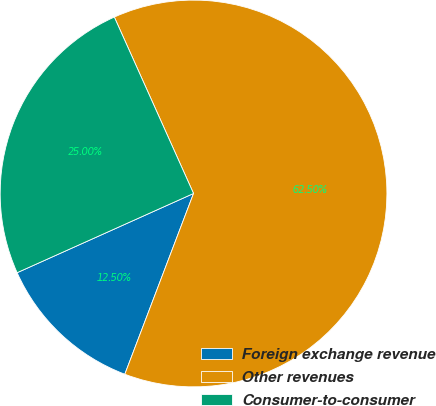Convert chart. <chart><loc_0><loc_0><loc_500><loc_500><pie_chart><fcel>Foreign exchange revenue<fcel>Other revenues<fcel>Consumer-to-consumer<nl><fcel>12.5%<fcel>62.5%<fcel>25.0%<nl></chart> 